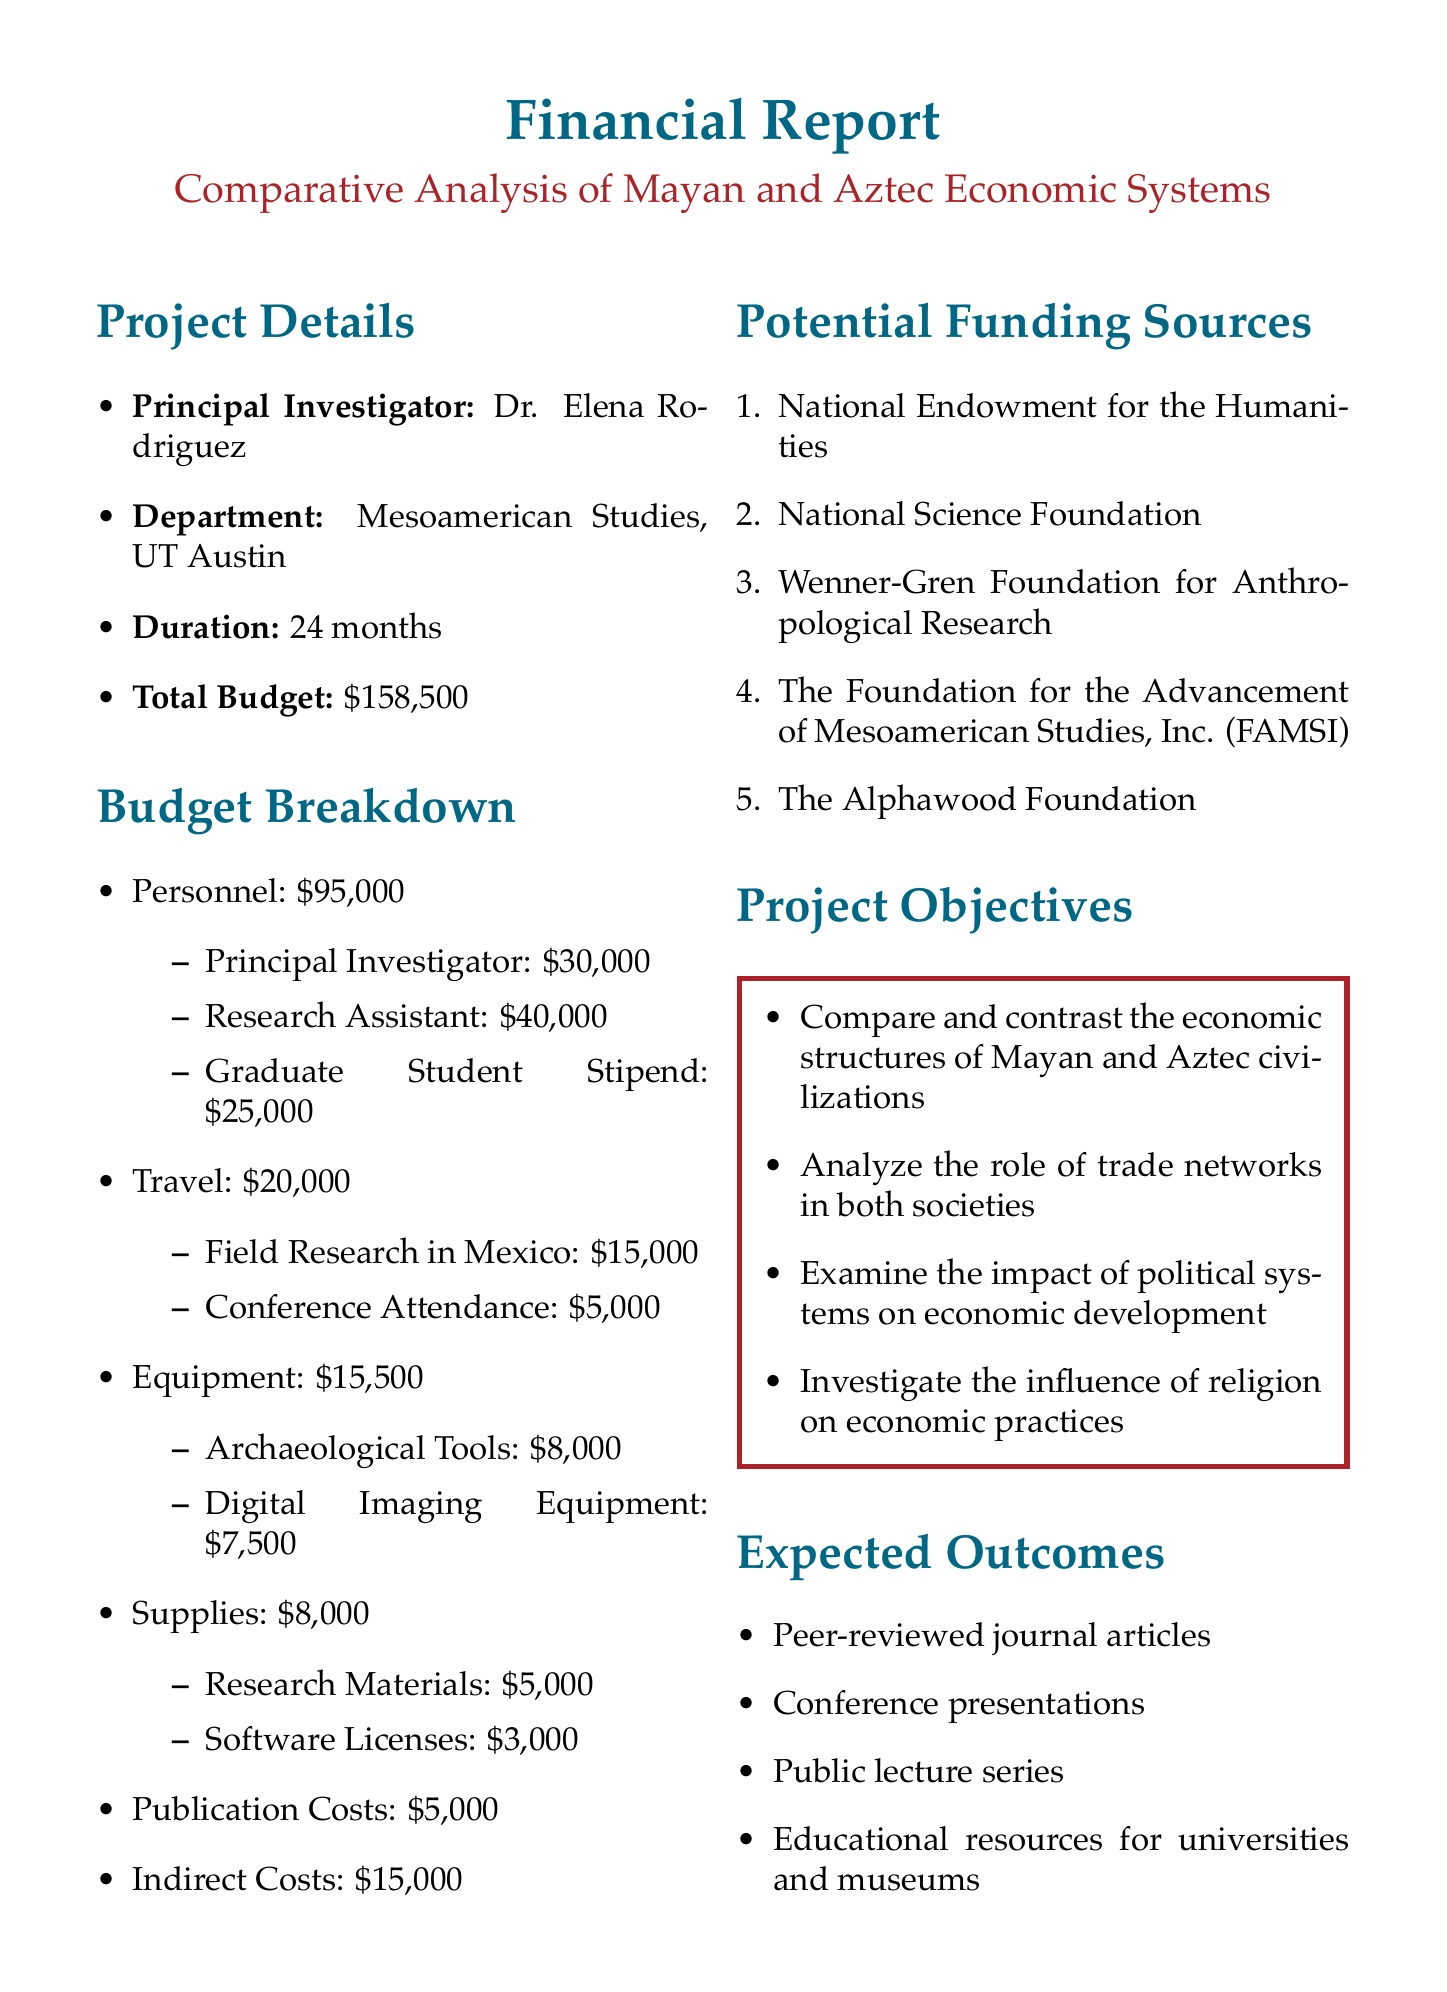What is the project title? The project title is the main focus of the financial report, which outlines the aim of the research.
Answer: Comparative Analysis of Mayan and Aztec Economic Systems: A Historical Perspective Who is the principal investigator? The principal investigator is the lead researcher responsible for the project.
Answer: Dr. Elena Rodriguez What is the total budget requested? The total budget requested represents the total amount of funding needed for the project.
Answer: $158,500 How long is the project duration? The project duration indicates the timeline over which the research will be conducted.
Answer: 24 months What is the budget allocated for travel? The budget allocated for travel specifies the funds set aside for travel-related expenses in the project.
Answer: $20,000 What is one of the expected outcomes of the project? The expected outcomes are the results or deliverables anticipated from the research once completed.
Answer: Peer-reviewed journal articles Name one potential funding source. Potential funding sources are organizations or foundations that may provide financial support for the project.
Answer: National Endowment for the Humanities What category has the highest budget allocation? This question examines the budget distribution to identify which category requires the most funding.
Answer: Personnel What is one of the objectives of the project? Project objectives outline the specific aims the research will focus on during its execution.
Answer: Analyze the role of trade networks in both societies 